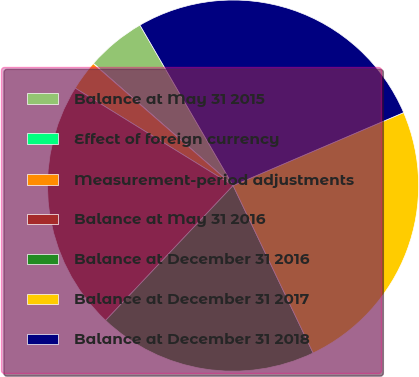Convert chart. <chart><loc_0><loc_0><loc_500><loc_500><pie_chart><fcel>Balance at May 31 2015<fcel>Effect of foreign currency<fcel>Measurement-period adjustments<fcel>Balance at May 31 2016<fcel>Balance at December 31 2016<fcel>Balance at December 31 2017<fcel>Balance at December 31 2018<nl><fcel>5.2%<fcel>0.02%<fcel>2.61%<fcel>21.75%<fcel>19.15%<fcel>24.34%<fcel>26.93%<nl></chart> 